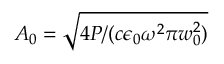<formula> <loc_0><loc_0><loc_500><loc_500>A _ { 0 } = \sqrt { 4 P / ( c \epsilon _ { 0 } \omega ^ { 2 } \pi w _ { 0 } ^ { 2 } ) }</formula> 